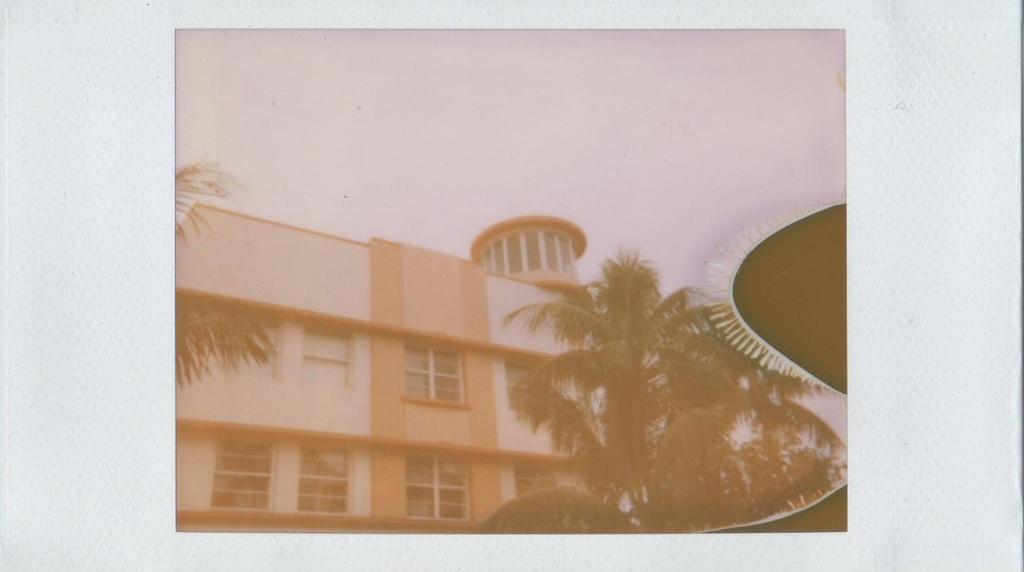What type of natural elements can be seen in the image? There are trees in the image. What type of structure is present in the image? There is a building with windows in the image. What is visible in the background of the image? The sky is visible in the background of the image. What type of religious symbols can be seen in the image? There are no religious symbols present in the image; it features trees, a building with windows, and the sky. What type of toys are visible in the image? There are no toys present in the image. 